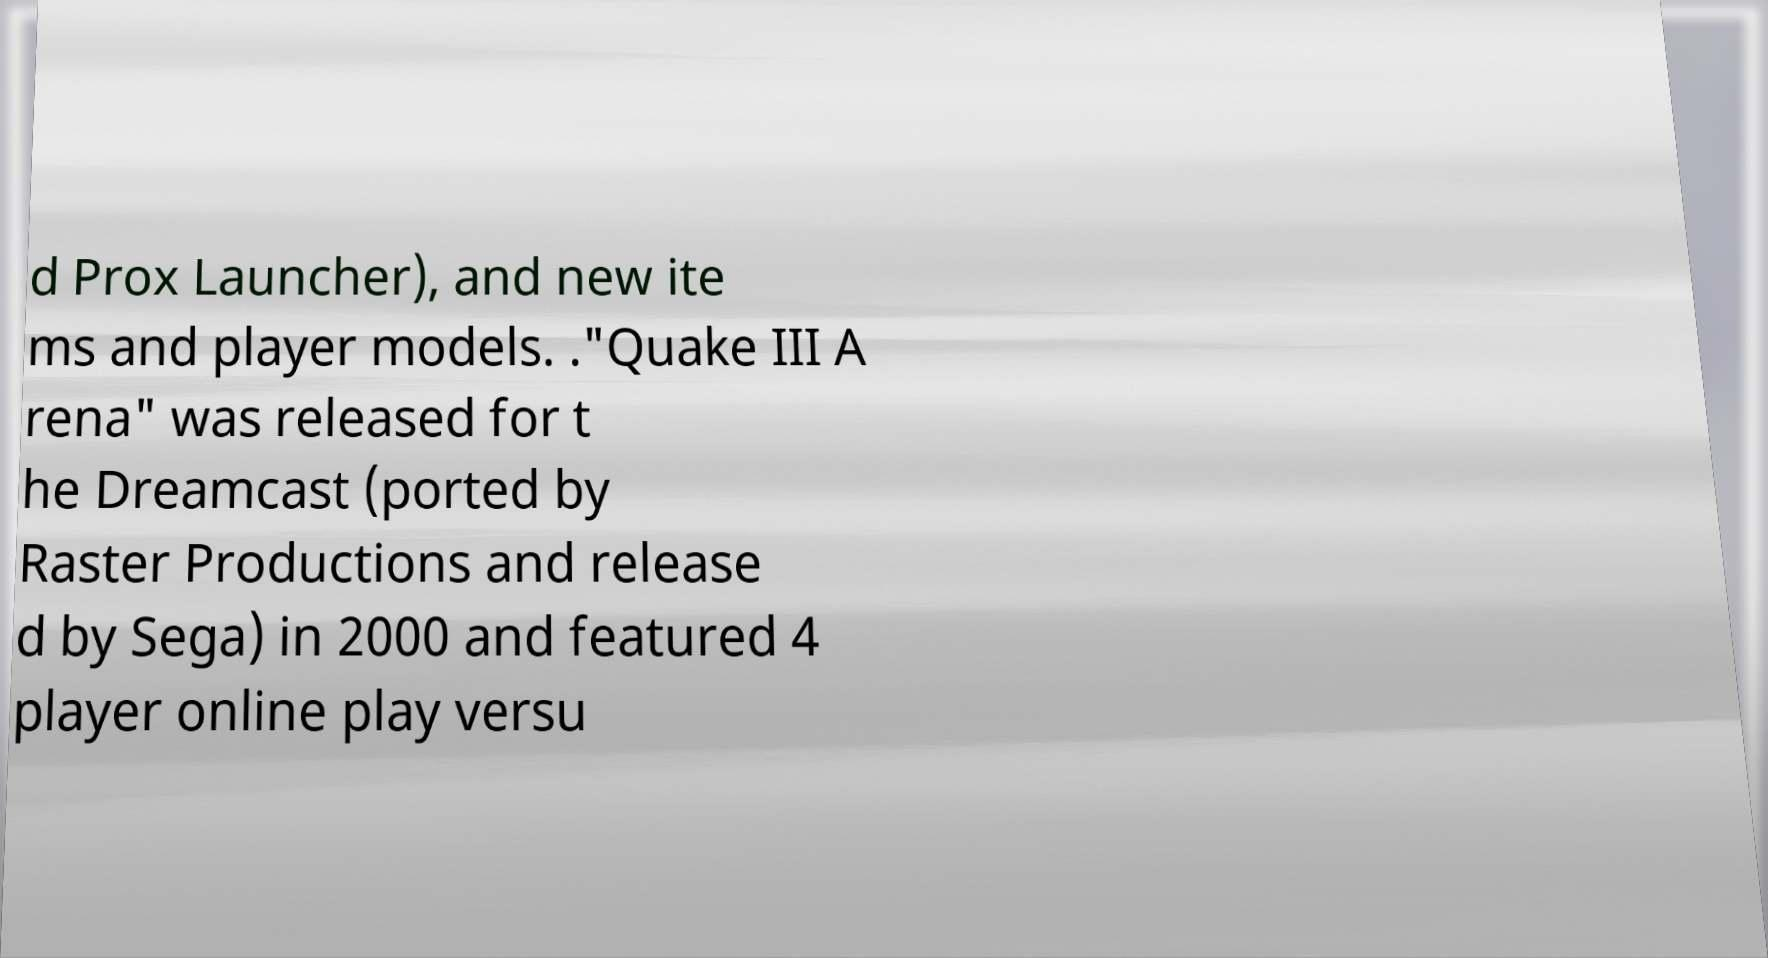Can you read and provide the text displayed in the image?This photo seems to have some interesting text. Can you extract and type it out for me? d Prox Launcher), and new ite ms and player models. ."Quake III A rena" was released for t he Dreamcast (ported by Raster Productions and release d by Sega) in 2000 and featured 4 player online play versu 